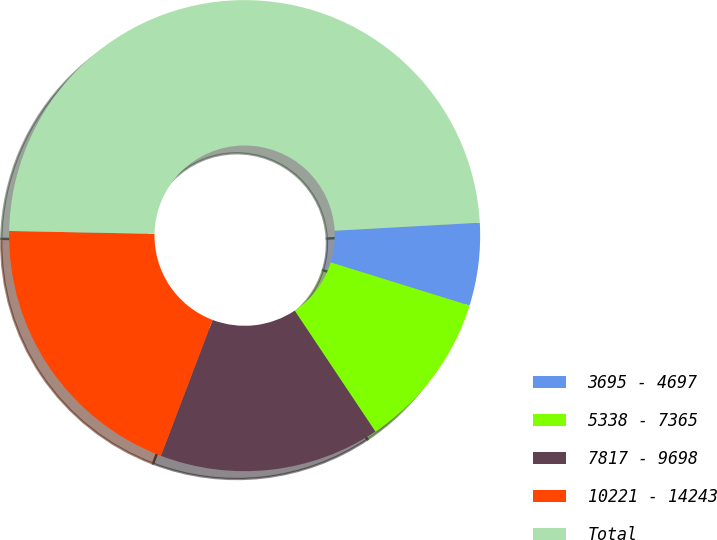<chart> <loc_0><loc_0><loc_500><loc_500><pie_chart><fcel>3695 - 4697<fcel>5338 - 7365<fcel>7817 - 9698<fcel>10221 - 14243<fcel>Total<nl><fcel>5.67%<fcel>10.84%<fcel>15.15%<fcel>19.53%<fcel>48.81%<nl></chart> 